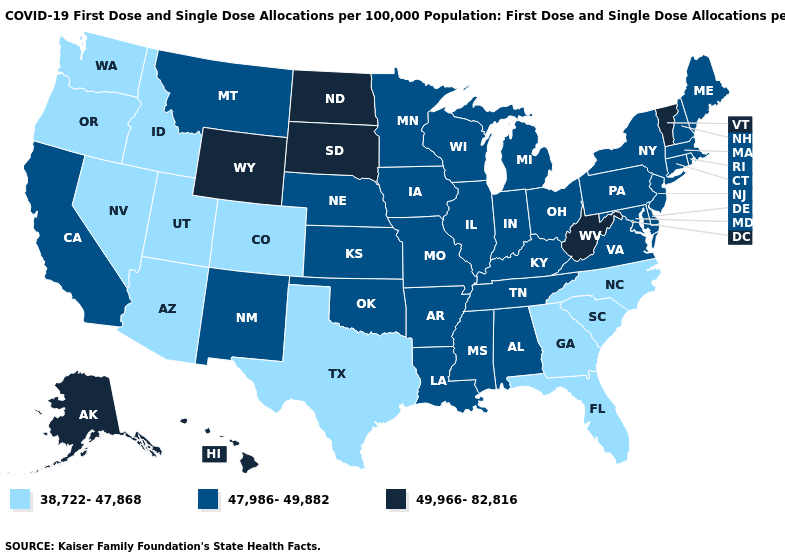Does Vermont have the highest value in the Northeast?
Give a very brief answer. Yes. What is the highest value in the USA?
Keep it brief. 49,966-82,816. Does Tennessee have the same value as New Mexico?
Concise answer only. Yes. Which states hav the highest value in the West?
Keep it brief. Alaska, Hawaii, Wyoming. Does New Hampshire have a lower value than Vermont?
Answer briefly. Yes. Does the map have missing data?
Write a very short answer. No. Does Utah have the lowest value in the USA?
Give a very brief answer. Yes. Name the states that have a value in the range 47,986-49,882?
Answer briefly. Alabama, Arkansas, California, Connecticut, Delaware, Illinois, Indiana, Iowa, Kansas, Kentucky, Louisiana, Maine, Maryland, Massachusetts, Michigan, Minnesota, Mississippi, Missouri, Montana, Nebraska, New Hampshire, New Jersey, New Mexico, New York, Ohio, Oklahoma, Pennsylvania, Rhode Island, Tennessee, Virginia, Wisconsin. What is the highest value in states that border Washington?
Answer briefly. 38,722-47,868. Which states have the lowest value in the MidWest?
Write a very short answer. Illinois, Indiana, Iowa, Kansas, Michigan, Minnesota, Missouri, Nebraska, Ohio, Wisconsin. What is the value of Missouri?
Concise answer only. 47,986-49,882. What is the value of Minnesota?
Give a very brief answer. 47,986-49,882. What is the lowest value in the South?
Be succinct. 38,722-47,868. Name the states that have a value in the range 47,986-49,882?
Keep it brief. Alabama, Arkansas, California, Connecticut, Delaware, Illinois, Indiana, Iowa, Kansas, Kentucky, Louisiana, Maine, Maryland, Massachusetts, Michigan, Minnesota, Mississippi, Missouri, Montana, Nebraska, New Hampshire, New Jersey, New Mexico, New York, Ohio, Oklahoma, Pennsylvania, Rhode Island, Tennessee, Virginia, Wisconsin. What is the lowest value in the USA?
Give a very brief answer. 38,722-47,868. 